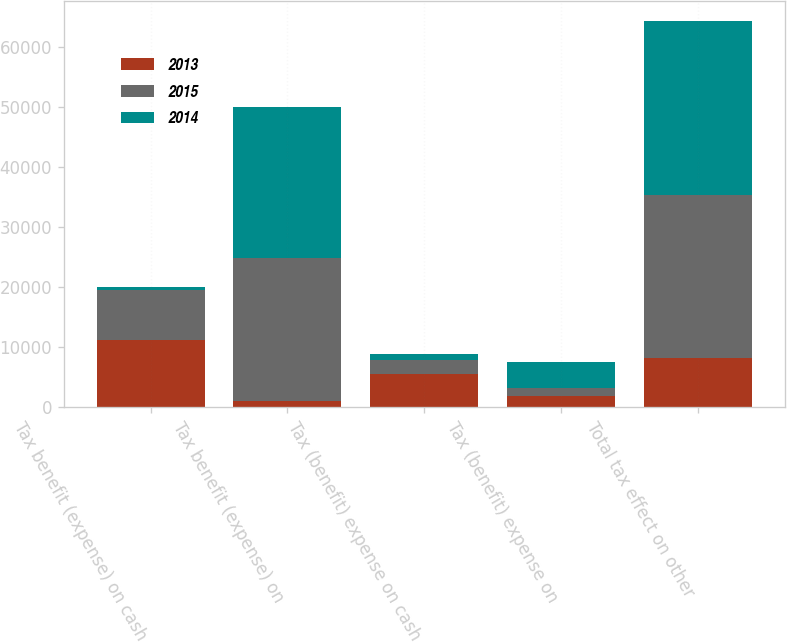Convert chart to OTSL. <chart><loc_0><loc_0><loc_500><loc_500><stacked_bar_chart><ecel><fcel>Tax benefit (expense) on cash<fcel>Tax benefit (expense) on<fcel>Tax (benefit) expense on cash<fcel>Tax (benefit) expense on<fcel>Total tax effect on other<nl><fcel>2013<fcel>11190<fcel>928<fcel>5435<fcel>1861<fcel>8180<nl><fcel>2015<fcel>8259<fcel>23869<fcel>2488<fcel>1327<fcel>27236<nl><fcel>2014<fcel>511<fcel>25193<fcel>946<fcel>4275<fcel>29033<nl></chart> 